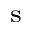Convert formula to latex. <formula><loc_0><loc_0><loc_500><loc_500>_ { s }</formula> 